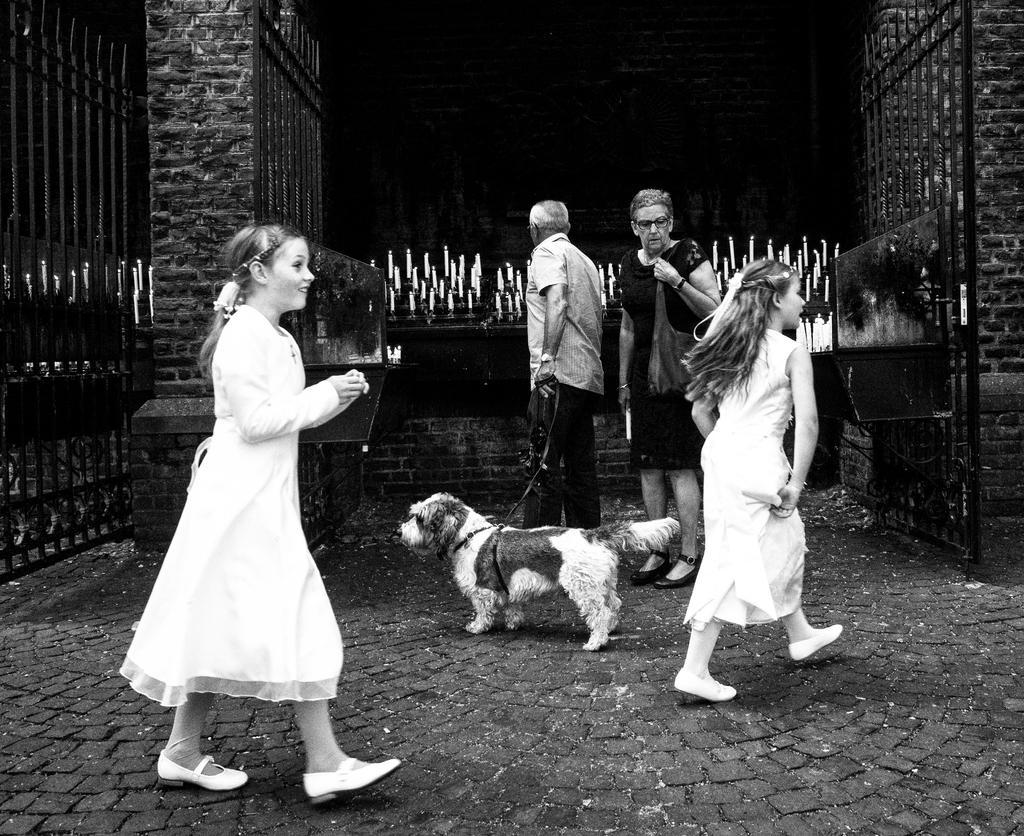Could you give a brief overview of what you see in this image? This is a picture, it is in black and white picture there are two girls in white dress walking on the floor and the man holding the belt of a dog and the women in black dress we're looking to the girl and the background of this people is a wall with bricks. 